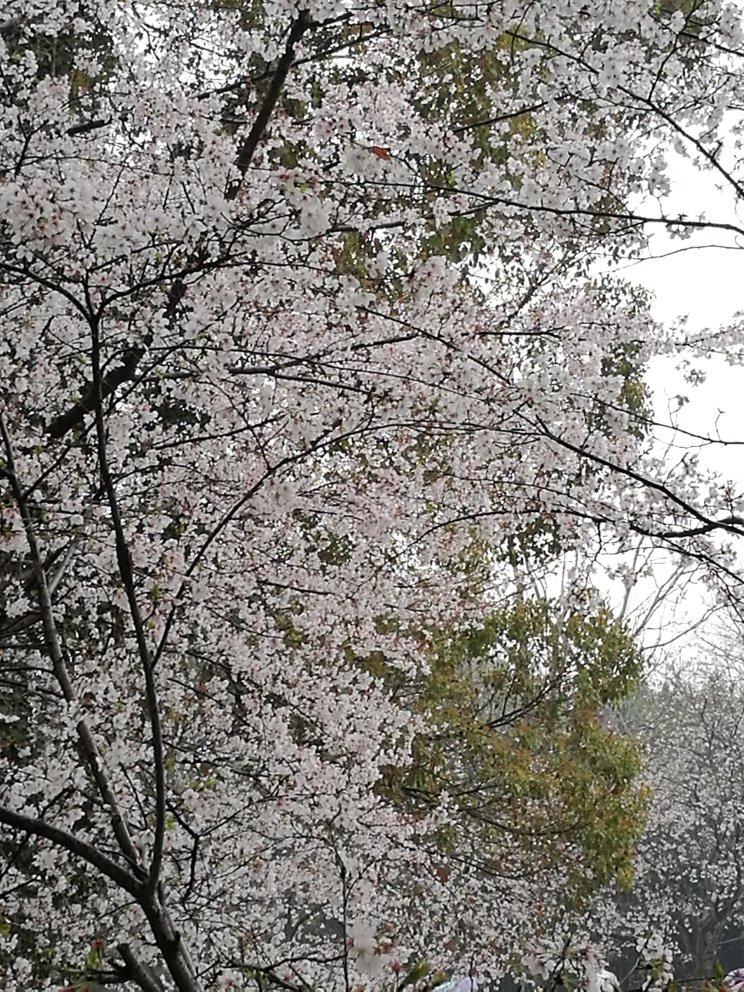What is your overall assessment of the image quality? The image showcasing tree branches covered in cherry blossoms has a moderate resolution and natural light. However, the overcast sky results in a somewhat flat lighting, and the image could benefit from increased contrast to highlight the delicate hues of the blossoms. 